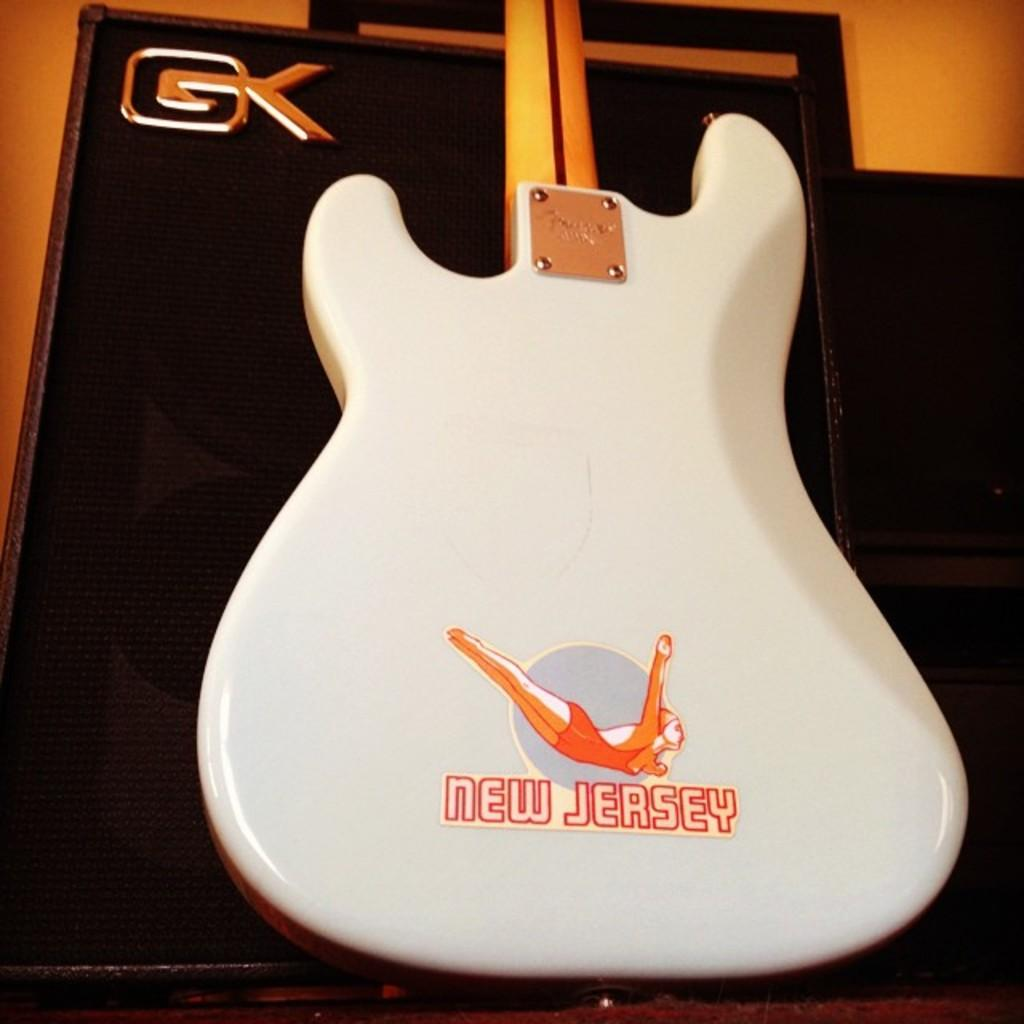What musical instrument is present in the image? There is a guitar in the image. Is there any writing or text on the guitar? Yes, there is text on the guitar. What type of creature is playing the guitar in the image? There is no creature present in the image; it only shows a guitar with text on it. Is there any smoke coming from the guitar in the image? No, there is no smoke present in the image. 